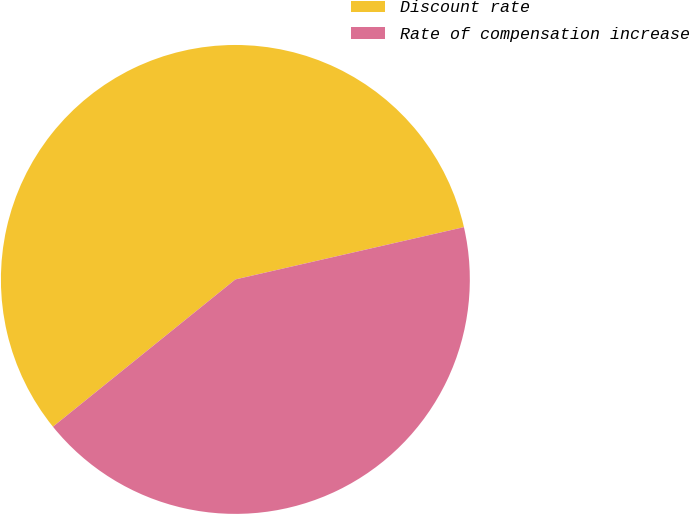<chart> <loc_0><loc_0><loc_500><loc_500><pie_chart><fcel>Discount rate<fcel>Rate of compensation increase<nl><fcel>57.23%<fcel>42.77%<nl></chart> 